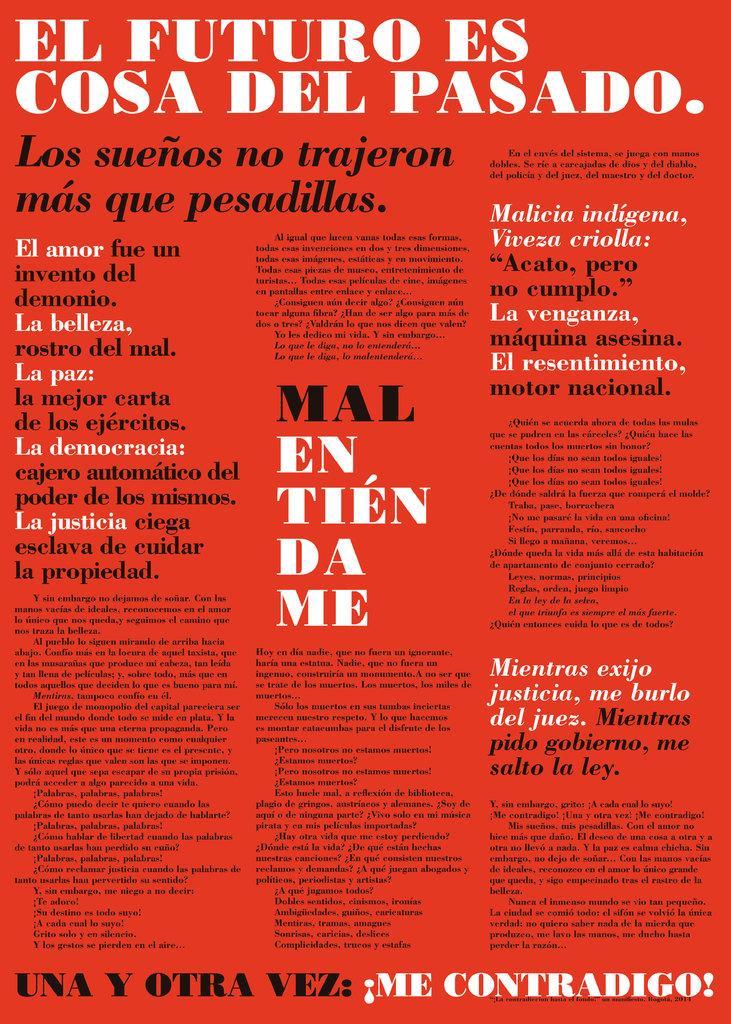In one or two sentences, can you explain what this image depicts? In this image we can see a red color poster with some text on it. 